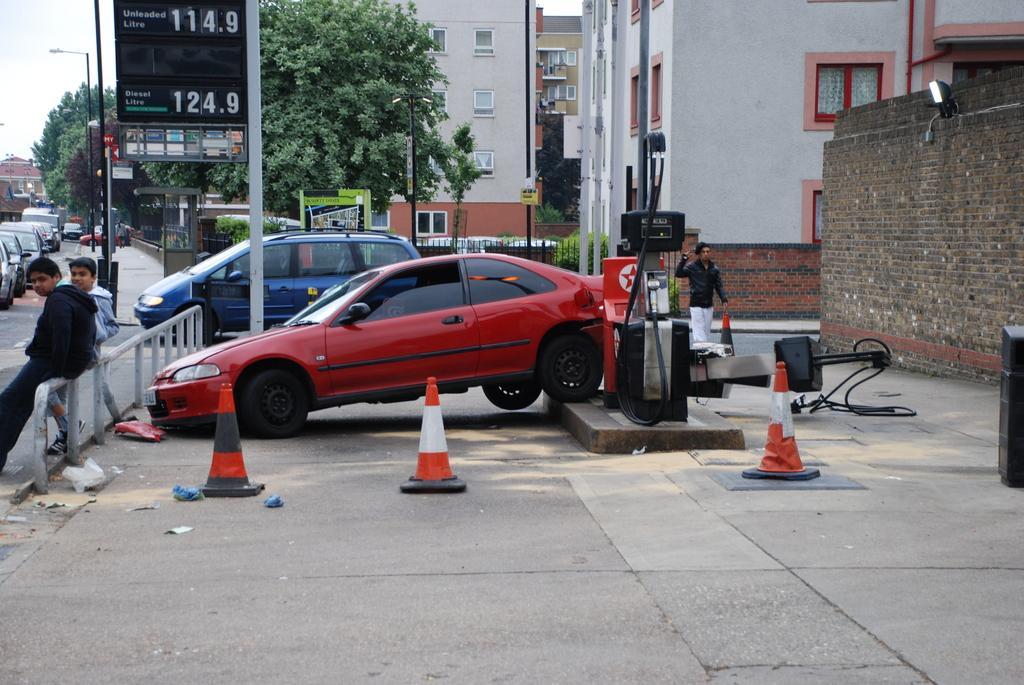Describe this image in one or two sentences. In this picture there are two persons standing near to the fencing. Backside of them we can see your red color car. Here we can see traffic cones near to the pole. On the right there is a man who is wearing black jacket and white trouser. He is standing near to the brick wall. On the background we can see buildings, tree, board, pole, plant, gate and street light. On the left background we can see many vehicles on the road. On the top left corner we can see sky and clouds. 